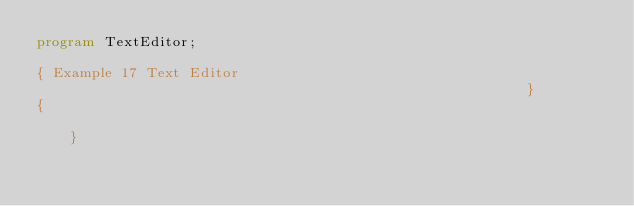Convert code to text. <code><loc_0><loc_0><loc_500><loc_500><_Pascal_>program TextEditor;

{ Example 17 Text Editor                                                       }
{                                                                              }</code> 